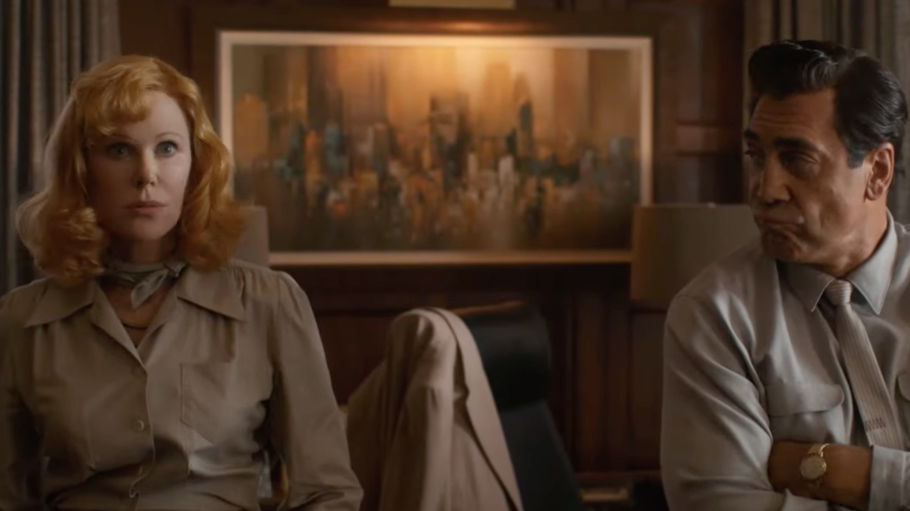What does the setting tell you about the themes or atmosphere of the film? The setting, with its rich wood paneling and an elaborate painting, suggests a backdrop of wealth, power, or history, likely important to the film's theme. It may reflect the high stakes involved or hint at the characters' social status or the power dynamics at play. The office-like environment combined with sophisticated attire hints at a professional or corporate conflict, emphasizing themes such as morality in business or the burdens of leadership. 